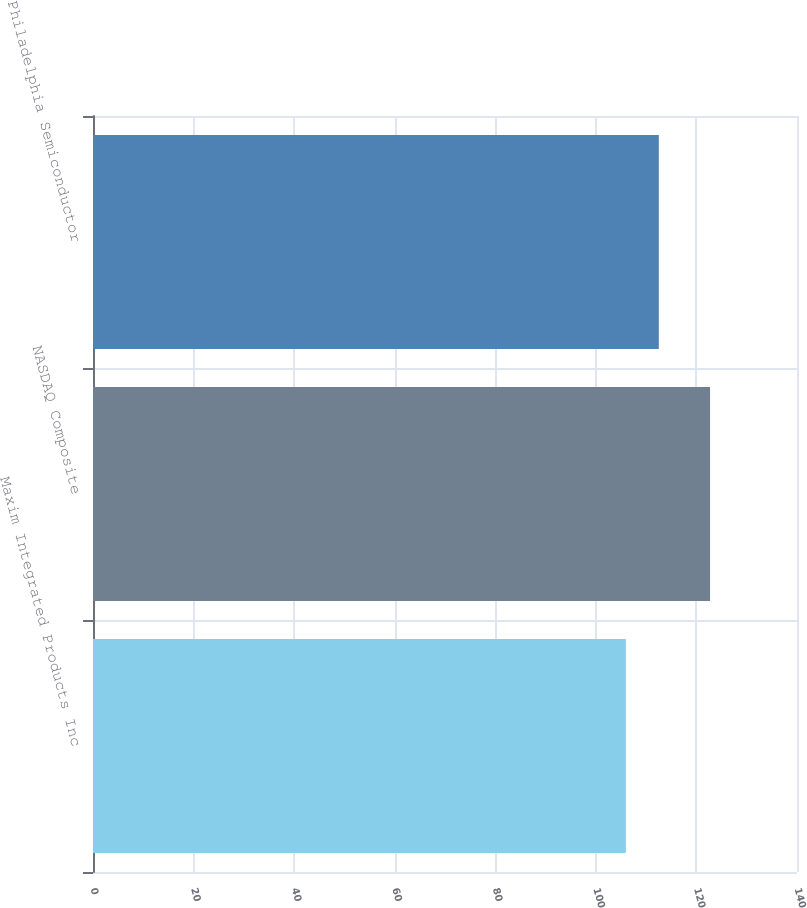Convert chart. <chart><loc_0><loc_0><loc_500><loc_500><bar_chart><fcel>Maxim Integrated Products Inc<fcel>NASDAQ Composite<fcel>Philadelphia Semiconductor<nl><fcel>105.97<fcel>122.71<fcel>112.52<nl></chart> 